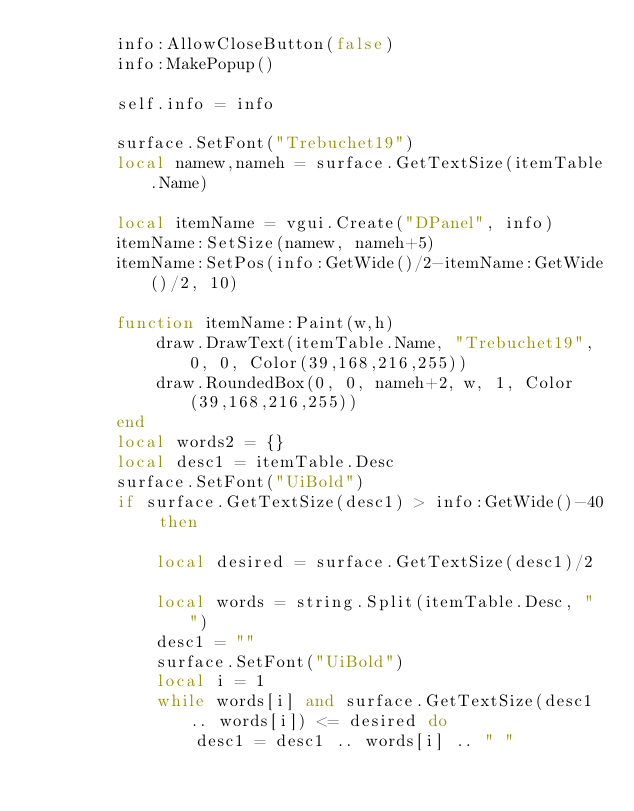<code> <loc_0><loc_0><loc_500><loc_500><_Lua_>        info:AllowCloseButton(false)
        info:MakePopup()
        
        self.info = info
        
        surface.SetFont("Trebuchet19")
        local namew,nameh = surface.GetTextSize(itemTable.Name)
        
        local itemName = vgui.Create("DPanel", info)
        itemName:SetSize(namew, nameh+5)
        itemName:SetPos(info:GetWide()/2-itemName:GetWide()/2, 10)
        
        function itemName:Paint(w,h)
            draw.DrawText(itemTable.Name, "Trebuchet19", 0, 0, Color(39,168,216,255))
            draw.RoundedBox(0, 0, nameh+2, w, 1, Color(39,168,216,255))
        end
        local words2 = {}
        local desc1 = itemTable.Desc
        surface.SetFont("UiBold")
        if surface.GetTextSize(desc1) > info:GetWide()-40 then
        
            local desired = surface.GetTextSize(desc1)/2
        
            local words = string.Split(itemTable.Desc, " ")
            desc1 = ""
            surface.SetFont("UiBold")
            local i = 1
            while words[i] and surface.GetTextSize(desc1 .. words[i]) <= desired do
                desc1 = desc1 .. words[i] .. " "</code> 